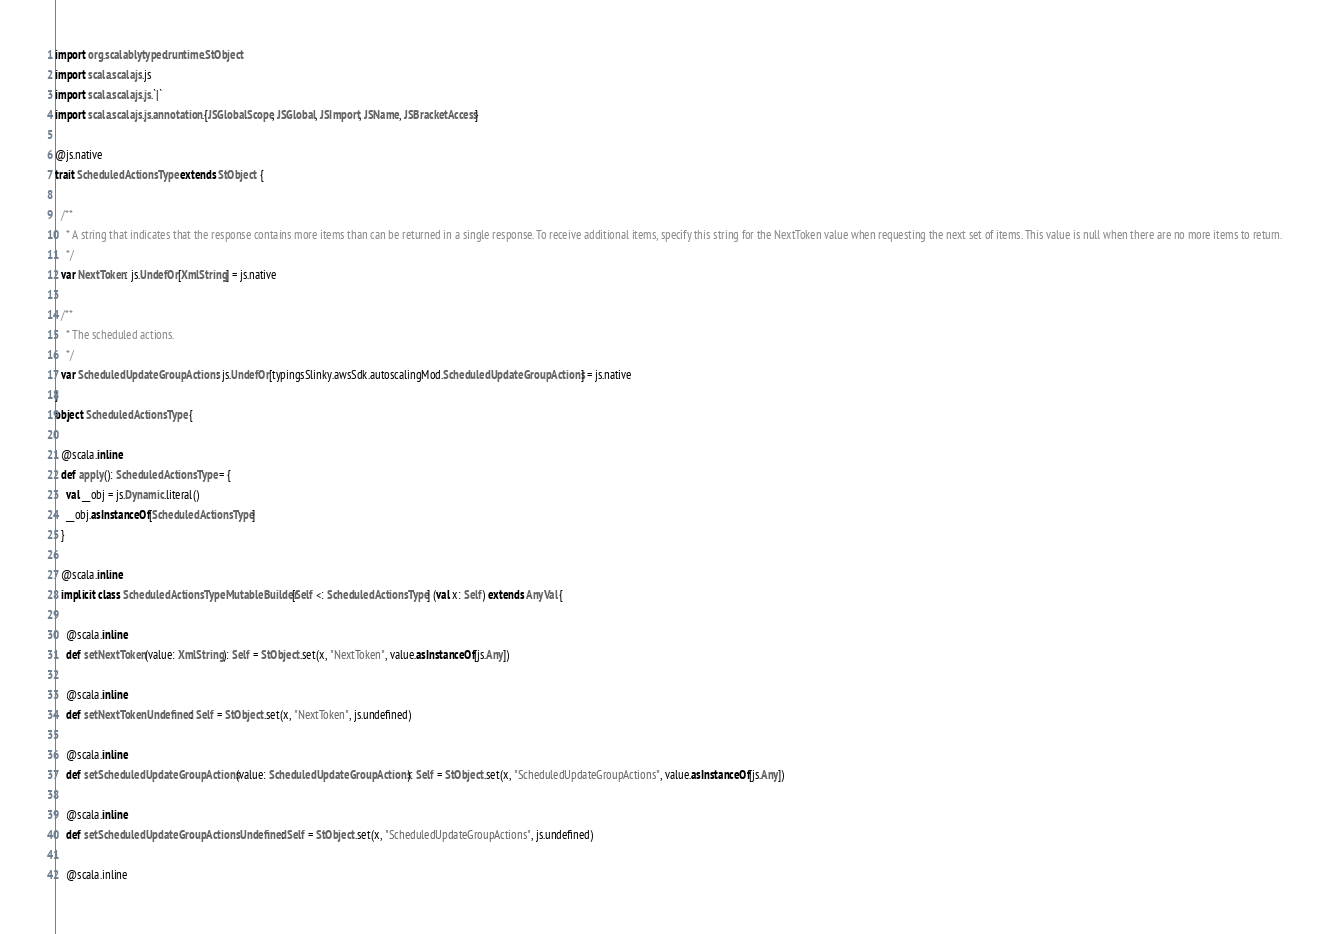<code> <loc_0><loc_0><loc_500><loc_500><_Scala_>import org.scalablytyped.runtime.StObject
import scala.scalajs.js
import scala.scalajs.js.`|`
import scala.scalajs.js.annotation.{JSGlobalScope, JSGlobal, JSImport, JSName, JSBracketAccess}

@js.native
trait ScheduledActionsType extends StObject {
  
  /**
    * A string that indicates that the response contains more items than can be returned in a single response. To receive additional items, specify this string for the NextToken value when requesting the next set of items. This value is null when there are no more items to return.
    */
  var NextToken: js.UndefOr[XmlString] = js.native
  
  /**
    * The scheduled actions.
    */
  var ScheduledUpdateGroupActions: js.UndefOr[typingsSlinky.awsSdk.autoscalingMod.ScheduledUpdateGroupActions] = js.native
}
object ScheduledActionsType {
  
  @scala.inline
  def apply(): ScheduledActionsType = {
    val __obj = js.Dynamic.literal()
    __obj.asInstanceOf[ScheduledActionsType]
  }
  
  @scala.inline
  implicit class ScheduledActionsTypeMutableBuilder[Self <: ScheduledActionsType] (val x: Self) extends AnyVal {
    
    @scala.inline
    def setNextToken(value: XmlString): Self = StObject.set(x, "NextToken", value.asInstanceOf[js.Any])
    
    @scala.inline
    def setNextTokenUndefined: Self = StObject.set(x, "NextToken", js.undefined)
    
    @scala.inline
    def setScheduledUpdateGroupActions(value: ScheduledUpdateGroupActions): Self = StObject.set(x, "ScheduledUpdateGroupActions", value.asInstanceOf[js.Any])
    
    @scala.inline
    def setScheduledUpdateGroupActionsUndefined: Self = StObject.set(x, "ScheduledUpdateGroupActions", js.undefined)
    
    @scala.inline</code> 